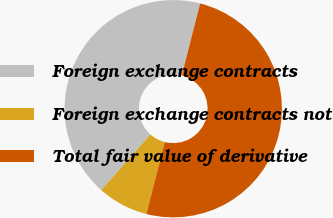<chart> <loc_0><loc_0><loc_500><loc_500><pie_chart><fcel>Foreign exchange contracts<fcel>Foreign exchange contracts not<fcel>Total fair value of derivative<nl><fcel>42.45%<fcel>7.55%<fcel>50.0%<nl></chart> 